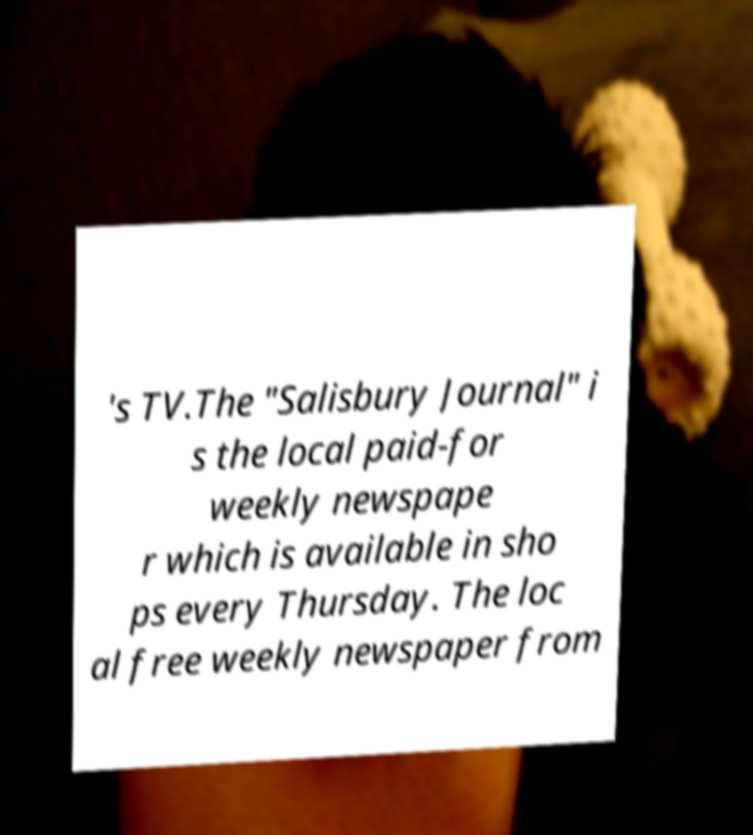Can you read and provide the text displayed in the image?This photo seems to have some interesting text. Can you extract and type it out for me? 's TV.The "Salisbury Journal" i s the local paid-for weekly newspape r which is available in sho ps every Thursday. The loc al free weekly newspaper from 